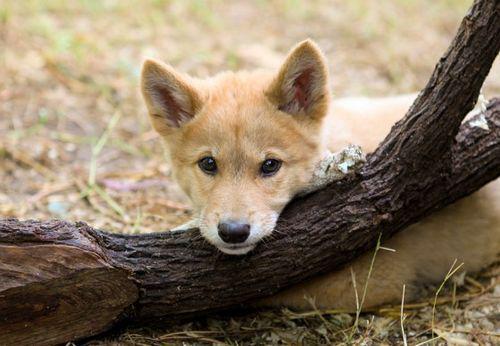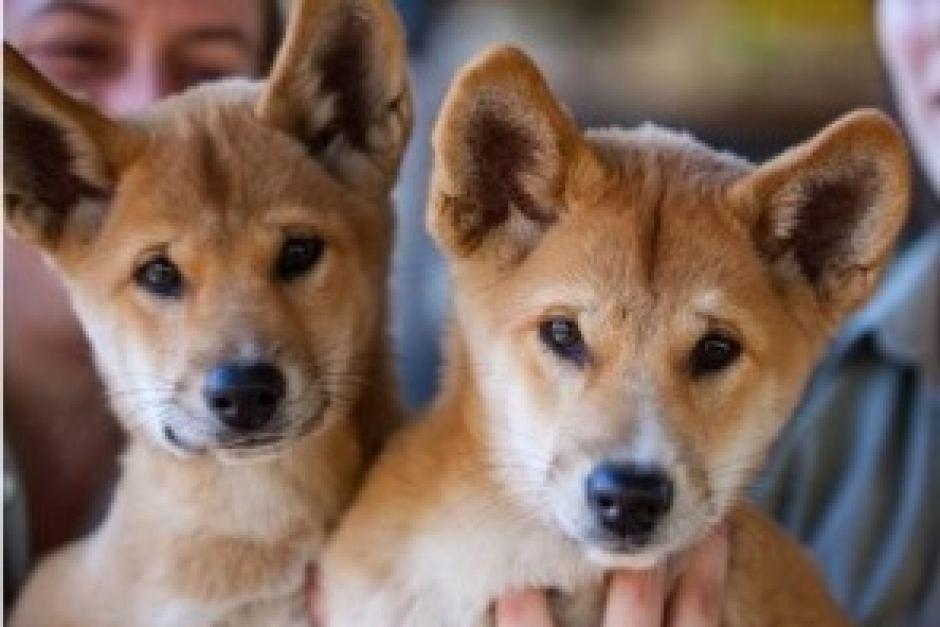The first image is the image on the left, the second image is the image on the right. Analyze the images presented: Is the assertion "In the image on the right there are 2 puppies." valid? Answer yes or no. Yes. The first image is the image on the left, the second image is the image on the right. Analyze the images presented: Is the assertion "At least one person is behind exactly two young dogs in the right image." valid? Answer yes or no. Yes. 